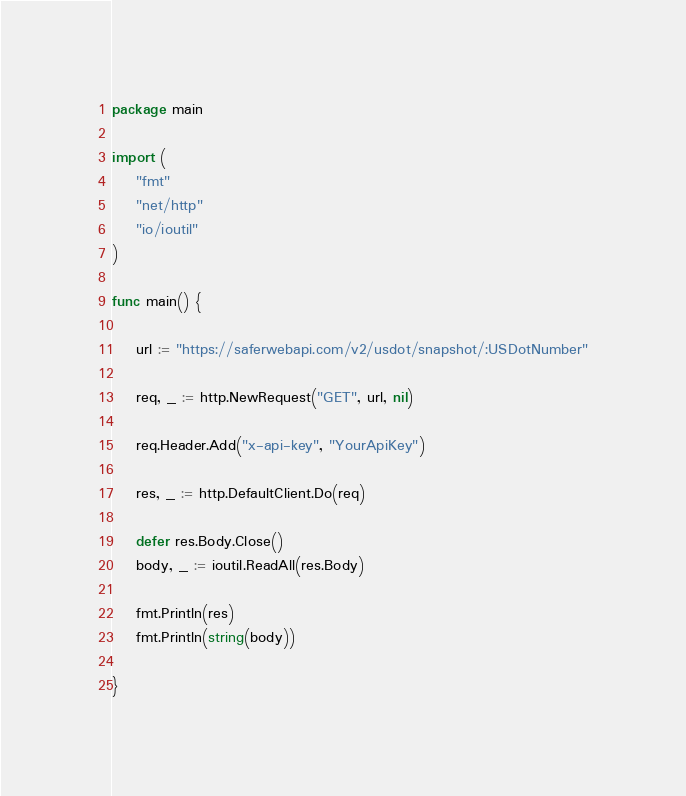Convert code to text. <code><loc_0><loc_0><loc_500><loc_500><_Go_>package main

import (
	"fmt"
	"net/http"
	"io/ioutil"
)

func main() {

	url := "https://saferwebapi.com/v2/usdot/snapshot/:USDotNumber"

	req, _ := http.NewRequest("GET", url, nil)

	req.Header.Add("x-api-key", "YourApiKey")

	res, _ := http.DefaultClient.Do(req)

	defer res.Body.Close()
	body, _ := ioutil.ReadAll(res.Body)

	fmt.Println(res)
	fmt.Println(string(body))

}
</code> 